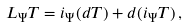Convert formula to latex. <formula><loc_0><loc_0><loc_500><loc_500>L _ { \Psi } T = i _ { \Psi } ( d T ) + d ( i _ { \Psi } T ) \, ,</formula> 